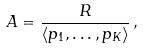Convert formula to latex. <formula><loc_0><loc_0><loc_500><loc_500>A = \frac { R } { \langle p _ { 1 } , \dots , p _ { K } \rangle } \, ,</formula> 